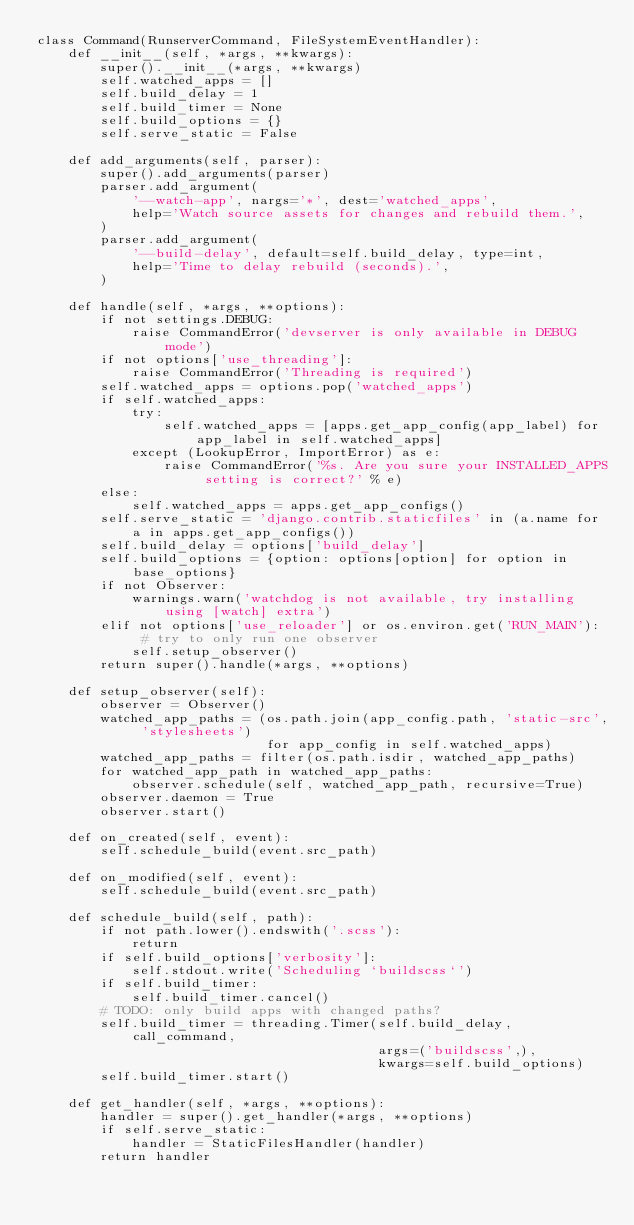Convert code to text. <code><loc_0><loc_0><loc_500><loc_500><_Python_>class Command(RunserverCommand, FileSystemEventHandler):
    def __init__(self, *args, **kwargs):
        super().__init__(*args, **kwargs)
        self.watched_apps = []
        self.build_delay = 1
        self.build_timer = None
        self.build_options = {}
        self.serve_static = False

    def add_arguments(self, parser):
        super().add_arguments(parser)
        parser.add_argument(
            '--watch-app', nargs='*', dest='watched_apps',
            help='Watch source assets for changes and rebuild them.',
        )
        parser.add_argument(
            '--build-delay', default=self.build_delay, type=int,
            help='Time to delay rebuild (seconds).',
        )

    def handle(self, *args, **options):
        if not settings.DEBUG:
            raise CommandError('devserver is only available in DEBUG mode')
        if not options['use_threading']:
            raise CommandError('Threading is required')
        self.watched_apps = options.pop('watched_apps')
        if self.watched_apps:
            try:
                self.watched_apps = [apps.get_app_config(app_label) for app_label in self.watched_apps]
            except (LookupError, ImportError) as e:
                raise CommandError('%s. Are you sure your INSTALLED_APPS setting is correct?' % e)
        else:
            self.watched_apps = apps.get_app_configs()
        self.serve_static = 'django.contrib.staticfiles' in (a.name for a in apps.get_app_configs())
        self.build_delay = options['build_delay']
        self.build_options = {option: options[option] for option in base_options}
        if not Observer:
            warnings.warn('watchdog is not available, try installing using [watch] extra')
        elif not options['use_reloader'] or os.environ.get('RUN_MAIN'):  # try to only run one observer
            self.setup_observer()
        return super().handle(*args, **options)

    def setup_observer(self):
        observer = Observer()
        watched_app_paths = (os.path.join(app_config.path, 'static-src', 'stylesheets')
                             for app_config in self.watched_apps)
        watched_app_paths = filter(os.path.isdir, watched_app_paths)
        for watched_app_path in watched_app_paths:
            observer.schedule(self, watched_app_path, recursive=True)
        observer.daemon = True
        observer.start()

    def on_created(self, event):
        self.schedule_build(event.src_path)

    def on_modified(self, event):
        self.schedule_build(event.src_path)

    def schedule_build(self, path):
        if not path.lower().endswith('.scss'):
            return
        if self.build_options['verbosity']:
            self.stdout.write('Scheduling `buildscss`')
        if self.build_timer:
            self.build_timer.cancel()
        # TODO: only build apps with changed paths?
        self.build_timer = threading.Timer(self.build_delay, call_command,
                                           args=('buildscss',),
                                           kwargs=self.build_options)
        self.build_timer.start()

    def get_handler(self, *args, **options):
        handler = super().get_handler(*args, **options)
        if self.serve_static:
            handler = StaticFilesHandler(handler)
        return handler
</code> 